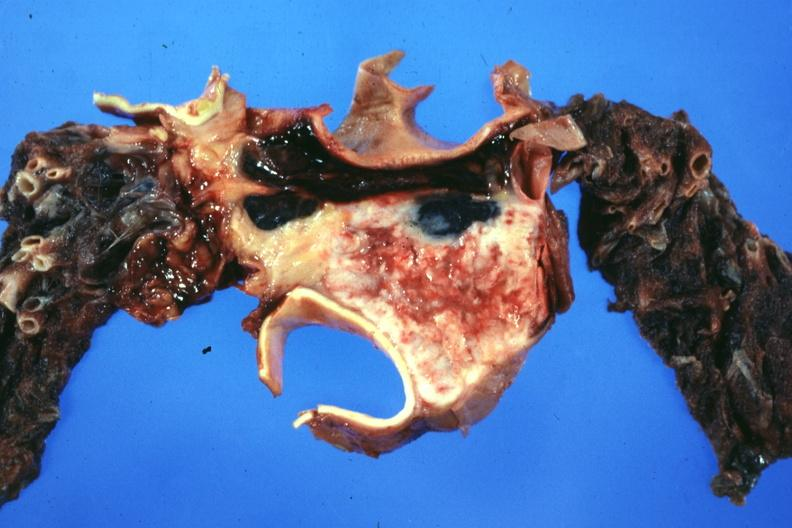does fracture show section through mediastinal structure showing tumor about aorta and pulmonary arteries?
Answer the question using a single word or phrase. No 